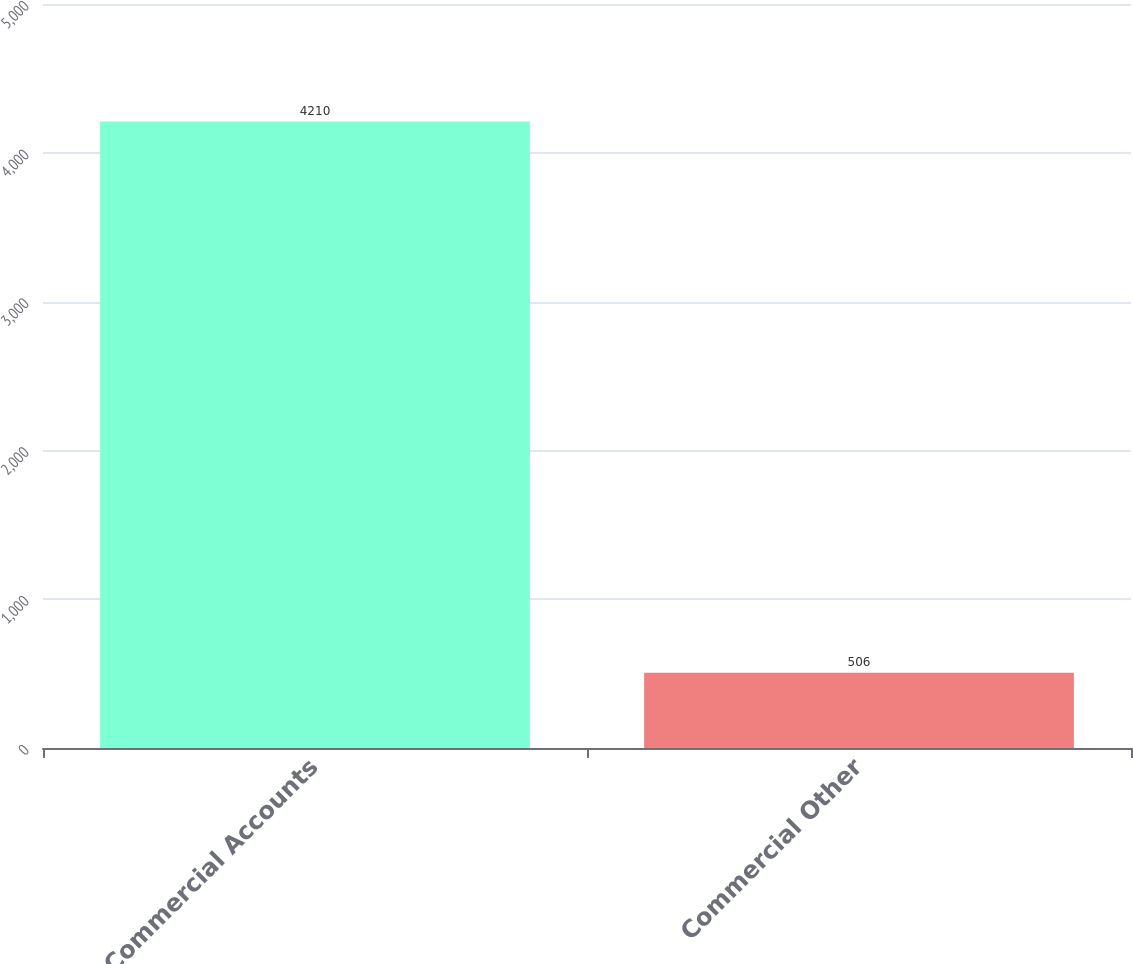Convert chart to OTSL. <chart><loc_0><loc_0><loc_500><loc_500><bar_chart><fcel>Commercial Accounts<fcel>Commercial Other<nl><fcel>4210<fcel>506<nl></chart> 